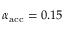<formula> <loc_0><loc_0><loc_500><loc_500>\alpha _ { a c c } = 0 . 1 5</formula> 